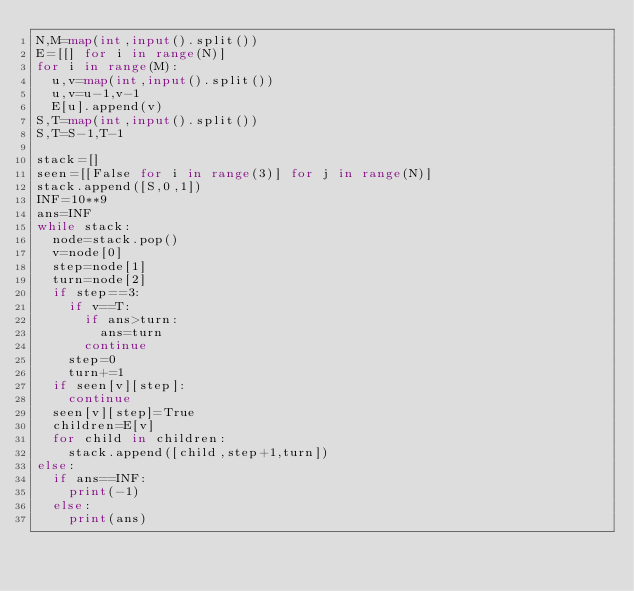<code> <loc_0><loc_0><loc_500><loc_500><_Python_>N,M=map(int,input().split())
E=[[] for i in range(N)]
for i in range(M):
  u,v=map(int,input().split())
  u,v=u-1,v-1
  E[u].append(v)
S,T=map(int,input().split())
S,T=S-1,T-1

stack=[]
seen=[[False for i in range(3)] for j in range(N)]
stack.append([S,0,1])
INF=10**9
ans=INF
while stack:
  node=stack.pop()
  v=node[0]
  step=node[1]
  turn=node[2]
  if step==3:
    if v==T:
      if ans>turn:
        ans=turn
      continue
    step=0
    turn+=1
  if seen[v][step]:
    continue
  seen[v][step]=True
  children=E[v]
  for child in children:
    stack.append([child,step+1,turn])
else:
  if ans==INF:
    print(-1)
  else:
    print(ans)
</code> 